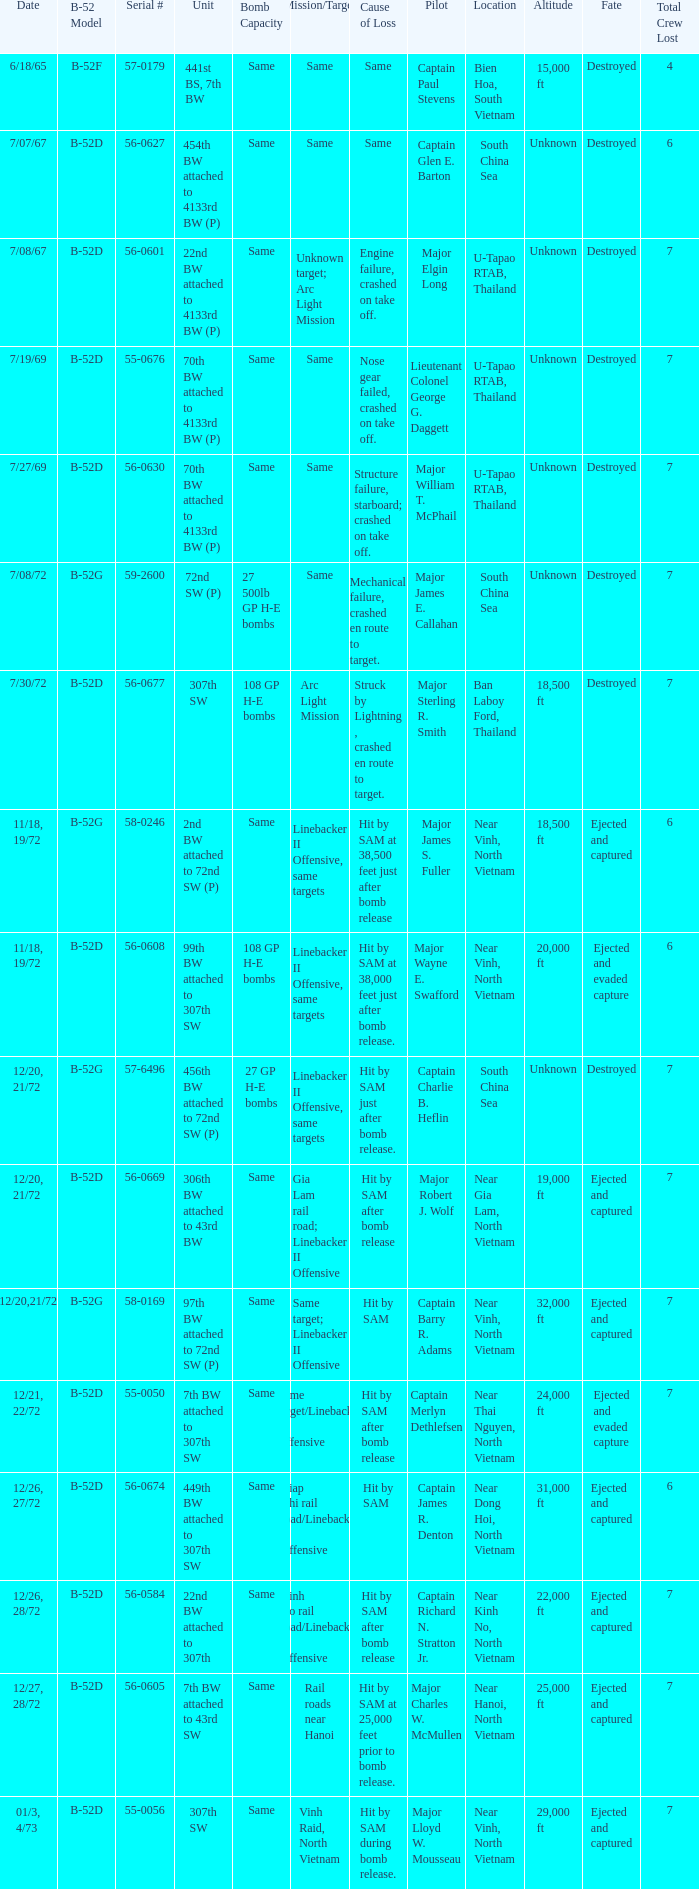When hit by sam at 38,500 feet just after bomb release was the cause of loss what is the mission/target? Linebacker II Offensive, same targets. 